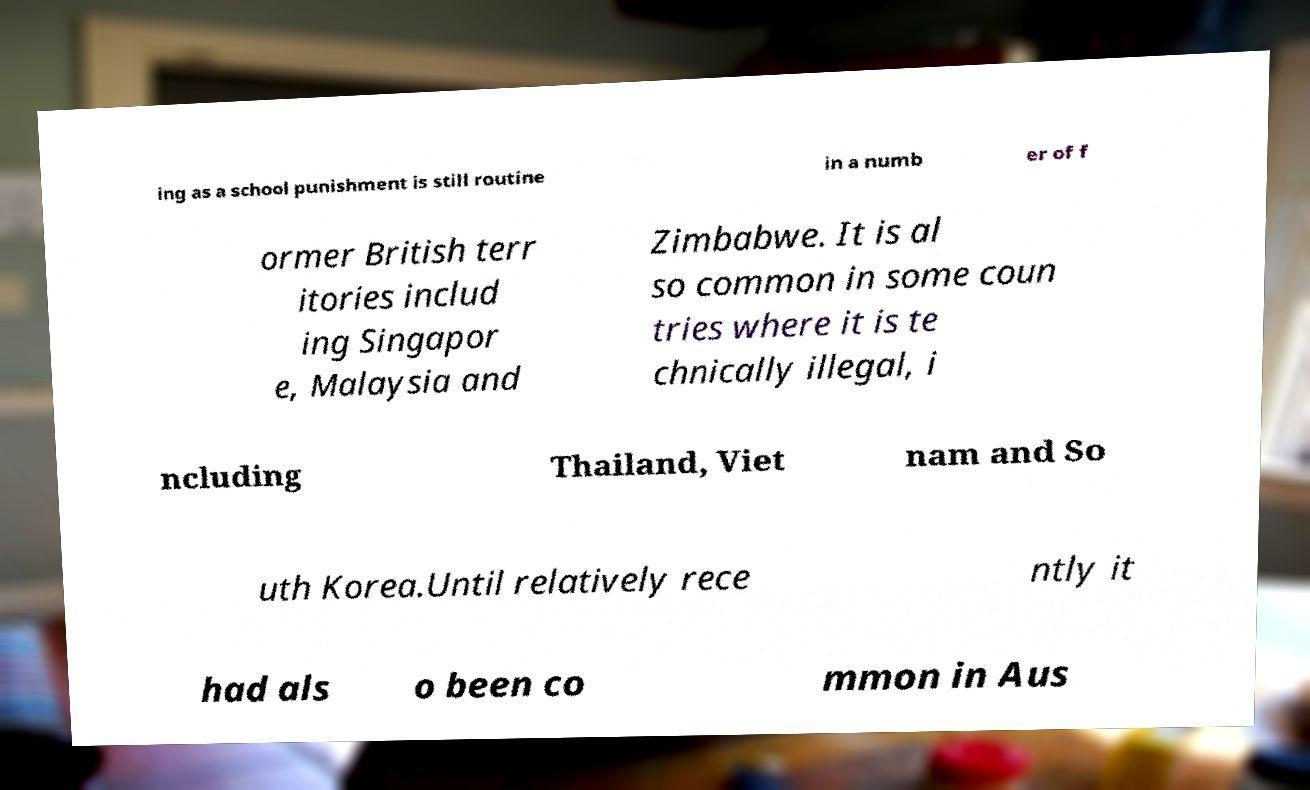There's text embedded in this image that I need extracted. Can you transcribe it verbatim? ing as a school punishment is still routine in a numb er of f ormer British terr itories includ ing Singapor e, Malaysia and Zimbabwe. It is al so common in some coun tries where it is te chnically illegal, i ncluding Thailand, Viet nam and So uth Korea.Until relatively rece ntly it had als o been co mmon in Aus 